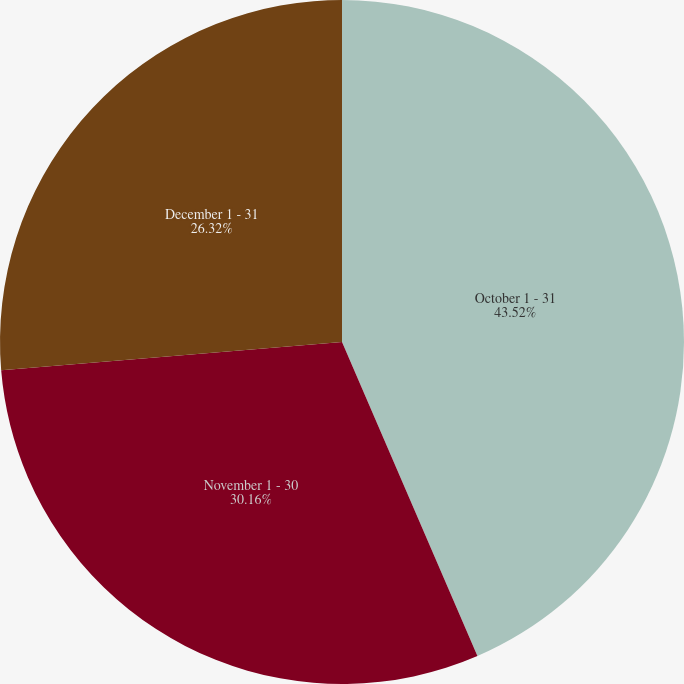Convert chart. <chart><loc_0><loc_0><loc_500><loc_500><pie_chart><fcel>October 1 - 31<fcel>November 1 - 30<fcel>December 1 - 31<nl><fcel>43.52%<fcel>30.16%<fcel>26.32%<nl></chart> 